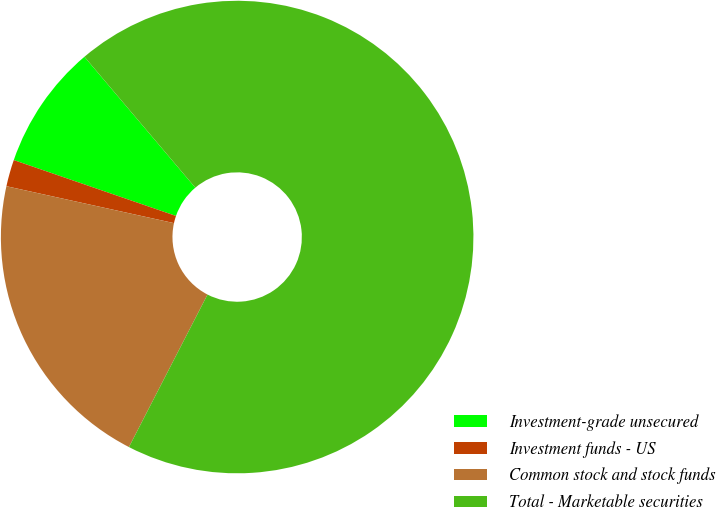Convert chart to OTSL. <chart><loc_0><loc_0><loc_500><loc_500><pie_chart><fcel>Investment-grade unsecured<fcel>Investment funds - US<fcel>Common stock and stock funds<fcel>Total - Marketable securities<nl><fcel>8.53%<fcel>1.83%<fcel>20.88%<fcel>68.76%<nl></chart> 